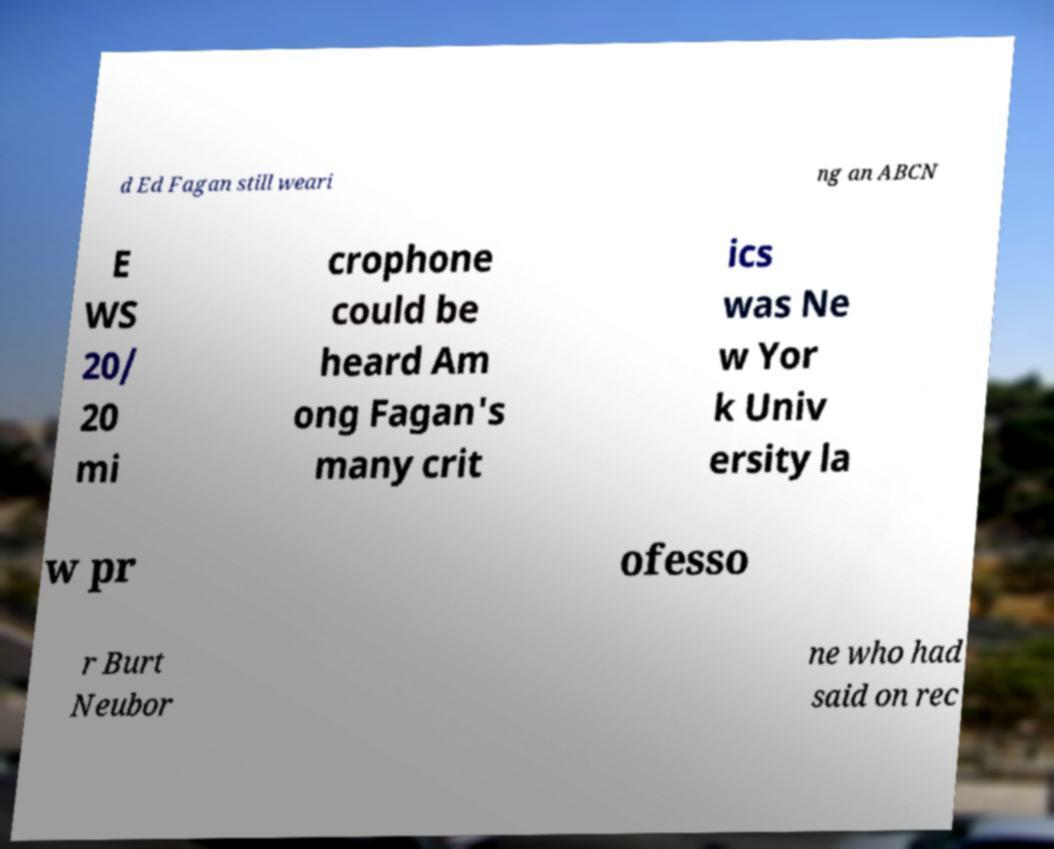For documentation purposes, I need the text within this image transcribed. Could you provide that? d Ed Fagan still weari ng an ABCN E WS 20/ 20 mi crophone could be heard Am ong Fagan's many crit ics was Ne w Yor k Univ ersity la w pr ofesso r Burt Neubor ne who had said on rec 